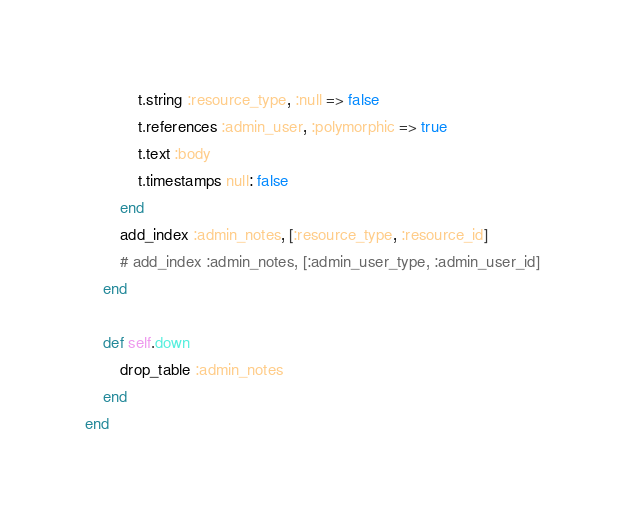Convert code to text. <code><loc_0><loc_0><loc_500><loc_500><_Ruby_>			t.string :resource_type, :null => false
			t.references :admin_user, :polymorphic => true
			t.text :body
			t.timestamps null: false
		end
		add_index :admin_notes, [:resource_type, :resource_id]
		# add_index :admin_notes, [:admin_user_type, :admin_user_id]
	end

	def self.down
		drop_table :admin_notes
	end
end
</code> 